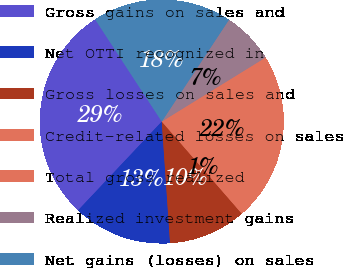Convert chart to OTSL. <chart><loc_0><loc_0><loc_500><loc_500><pie_chart><fcel>Gross gains on sales and<fcel>Net OTTI recognized in<fcel>Gross losses on sales and<fcel>Credit-related losses on sales<fcel>Total gross realized<fcel>Realized investment gains<fcel>Net gains (losses) on sales<nl><fcel>28.77%<fcel>13.12%<fcel>10.3%<fcel>0.56%<fcel>21.86%<fcel>6.91%<fcel>18.48%<nl></chart> 